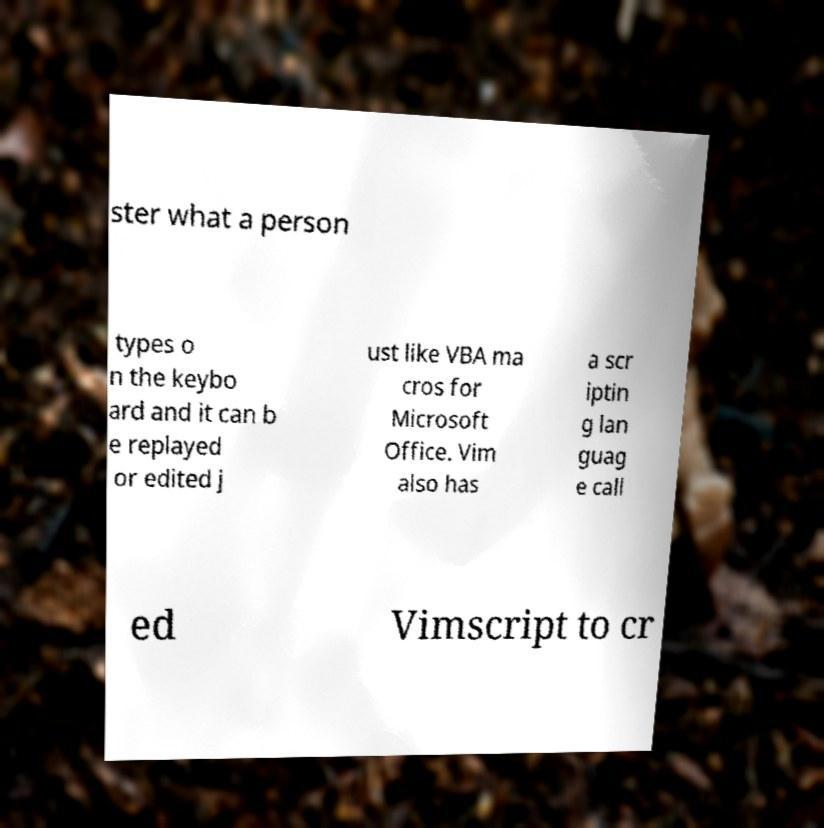Please read and relay the text visible in this image. What does it say? ster what a person types o n the keybo ard and it can b e replayed or edited j ust like VBA ma cros for Microsoft Office. Vim also has a scr iptin g lan guag e call ed Vimscript to cr 